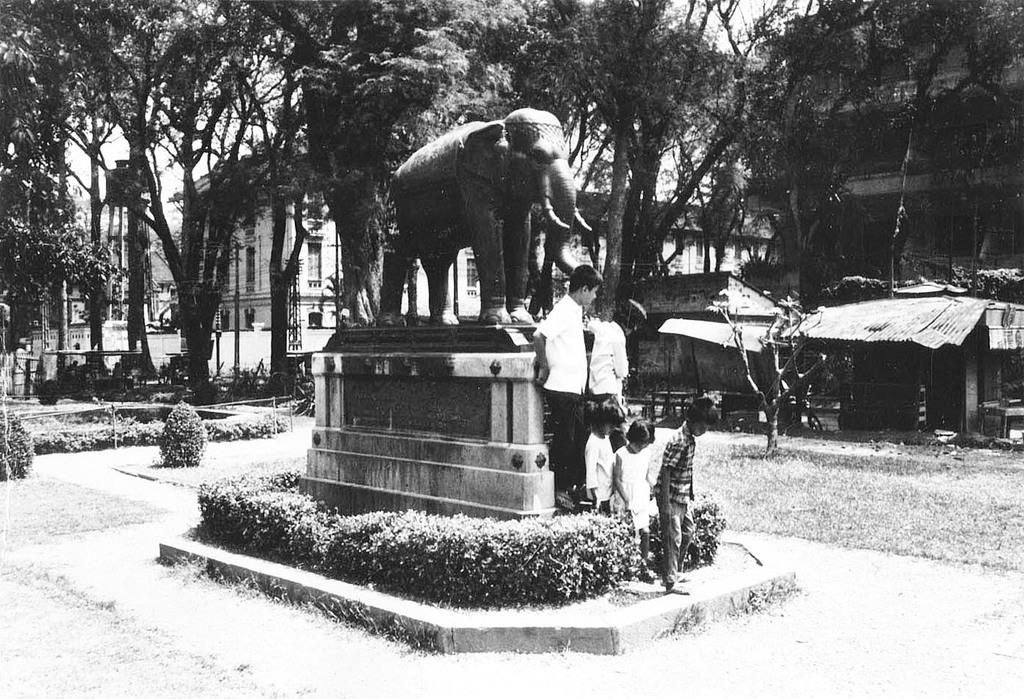What is the color scheme of the image? The image is black and white. What is the main subject in the center of the image? There is a statue in the center of the image. Can you describe the people in the image? There are persons in the image. What can be seen in the background of the image? There are trees, houses, sheds, and the sky visible in the background of the image. What type of cracker is being used to repair the ship in the image? There is no ship or cracker present in the image. What is the boundary between the trees and the houses in the image? The image does not show a boundary between the trees and the houses; it only shows them as separate elements in the background. 